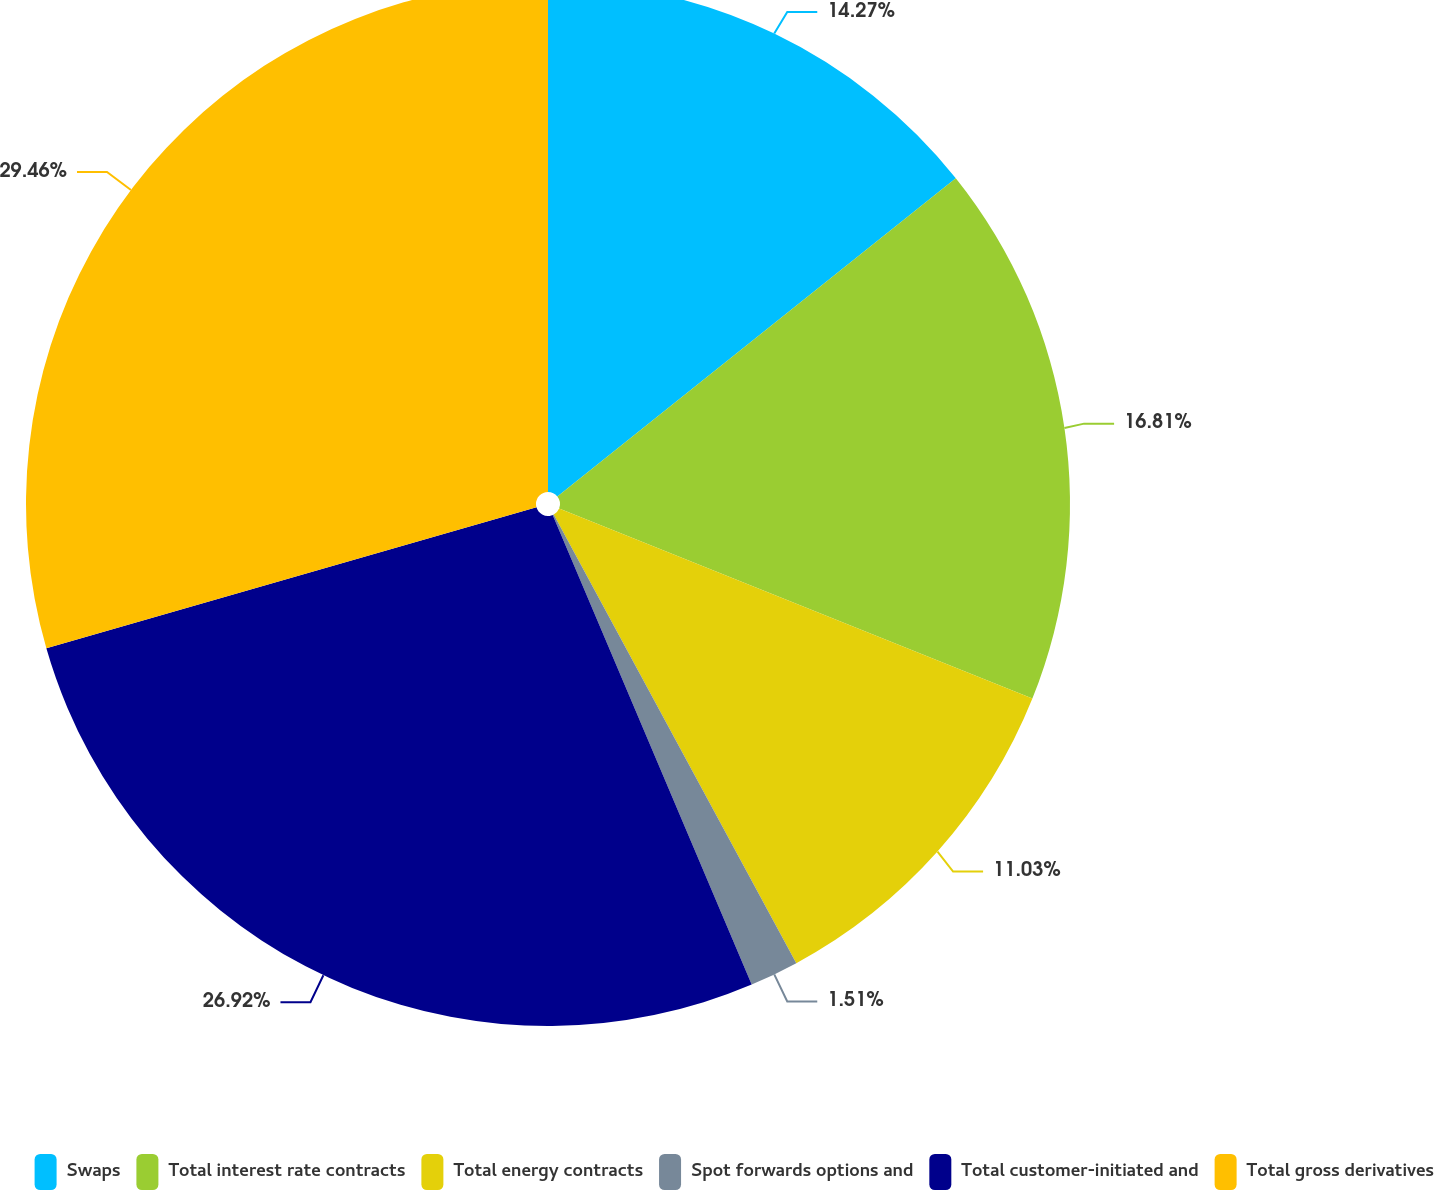Convert chart to OTSL. <chart><loc_0><loc_0><loc_500><loc_500><pie_chart><fcel>Swaps<fcel>Total interest rate contracts<fcel>Total energy contracts<fcel>Spot forwards options and<fcel>Total customer-initiated and<fcel>Total gross derivatives<nl><fcel>14.27%<fcel>16.81%<fcel>11.03%<fcel>1.51%<fcel>26.92%<fcel>29.46%<nl></chart> 